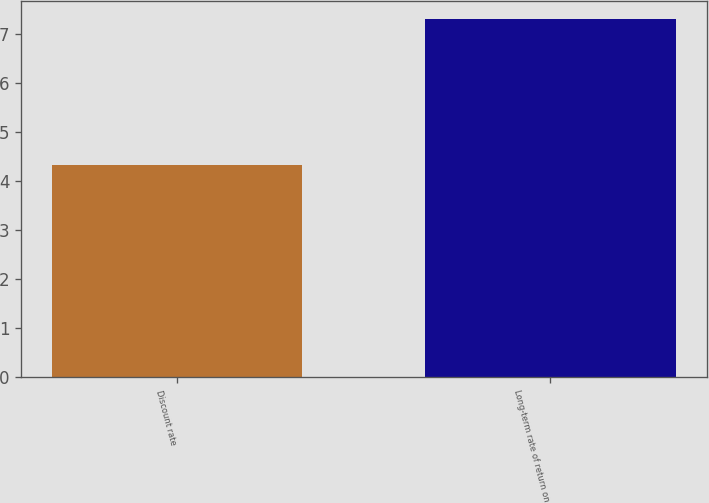<chart> <loc_0><loc_0><loc_500><loc_500><bar_chart><fcel>Discount rate<fcel>Long-term rate of return on<nl><fcel>4.32<fcel>7.3<nl></chart> 